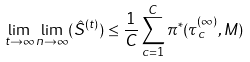Convert formula to latex. <formula><loc_0><loc_0><loc_500><loc_500>\lim _ { t \to \infty } \lim _ { n \to \infty } ( \hat { S } ^ { ( t ) } ) \leq \frac { 1 } { C } \sum _ { c = 1 } ^ { C } \pi ^ { * } ( \tau ^ { ( \infty ) } _ { c } , M )</formula> 